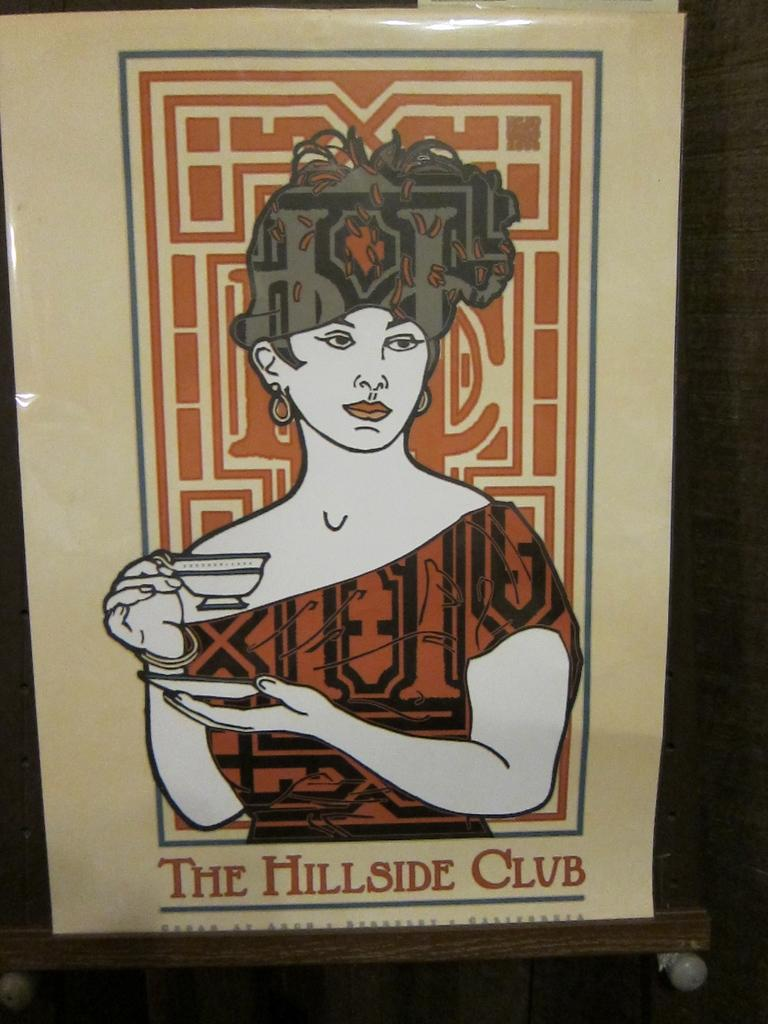What is on the wall in the image? There is a poster on a wall in the image. Can you see any snails climbing the wall near the poster in the image? There is no mention of snails or any climbing activity in the image; it only features a poster on a wall. 